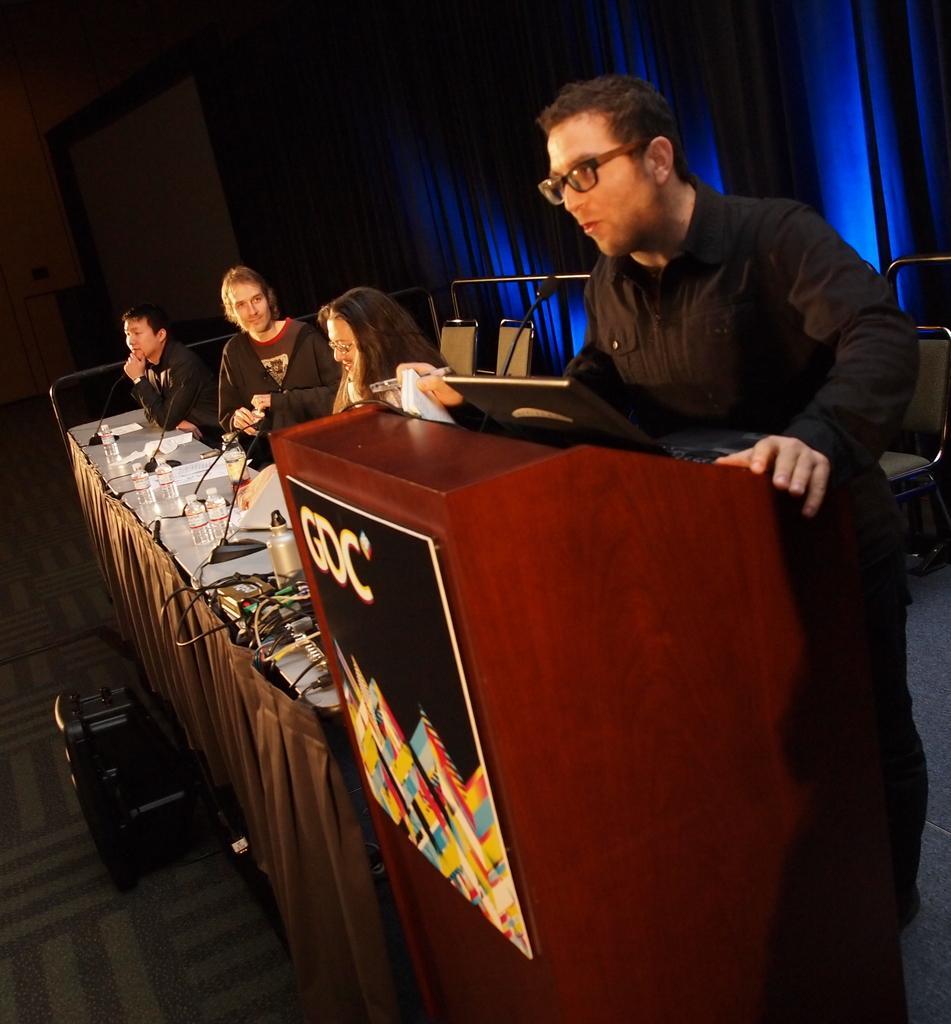Please provide a concise description of this image. This picture shows few people seated on the chairs and man standing at a podium and speaking with the help of a microphone and we see few water bottles and papers on the table 